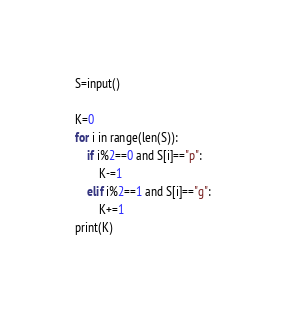<code> <loc_0><loc_0><loc_500><loc_500><_Python_>S=input()

K=0
for i in range(len(S)):
    if i%2==0 and S[i]=="p":
        K-=1
    elif i%2==1 and S[i]=="g":
        K+=1
print(K)</code> 